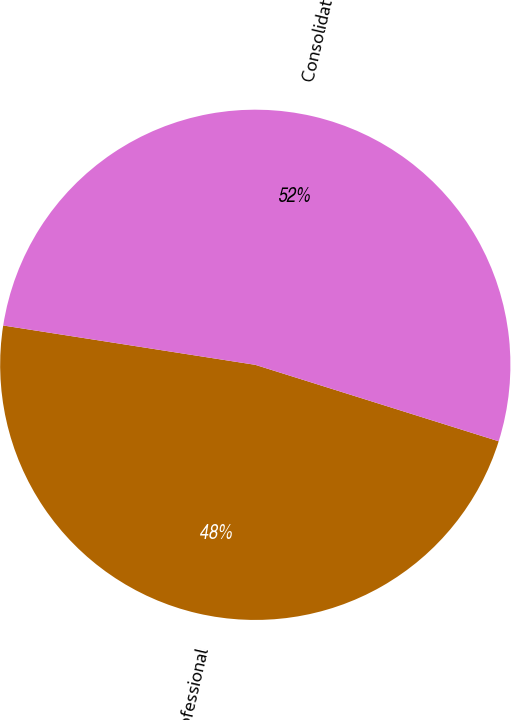<chart> <loc_0><loc_0><loc_500><loc_500><pie_chart><fcel>K-C Professional<fcel>Consolidated<nl><fcel>47.62%<fcel>52.38%<nl></chart> 